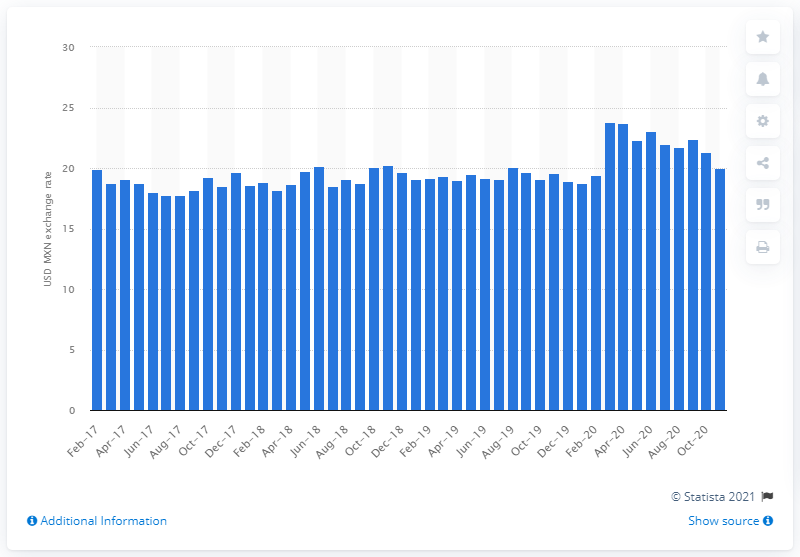Draw attention to some important aspects in this diagram. At the end of November 2020, one US dollar could buy approximately 20.04 Mexican pesos. 